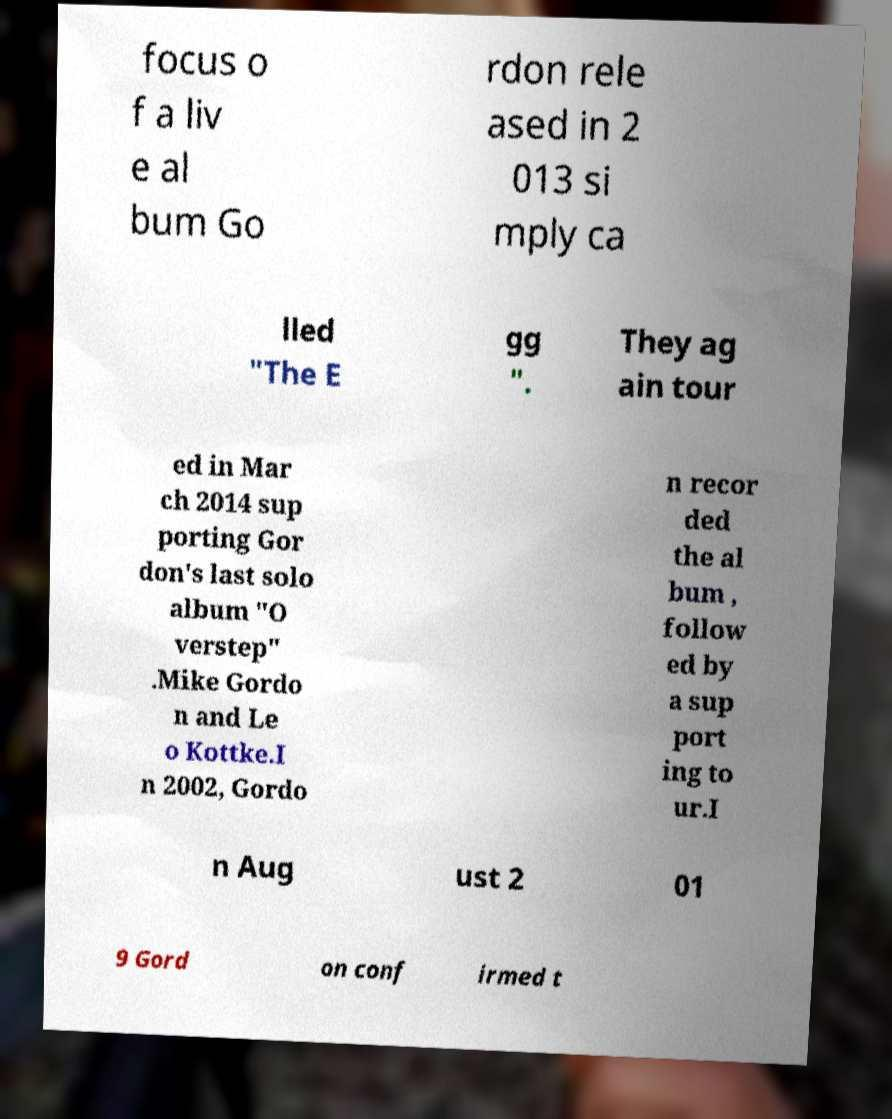What messages or text are displayed in this image? I need them in a readable, typed format. focus o f a liv e al bum Go rdon rele ased in 2 013 si mply ca lled "The E gg ". They ag ain tour ed in Mar ch 2014 sup porting Gor don's last solo album "O verstep" .Mike Gordo n and Le o Kottke.I n 2002, Gordo n recor ded the al bum , follow ed by a sup port ing to ur.I n Aug ust 2 01 9 Gord on conf irmed t 